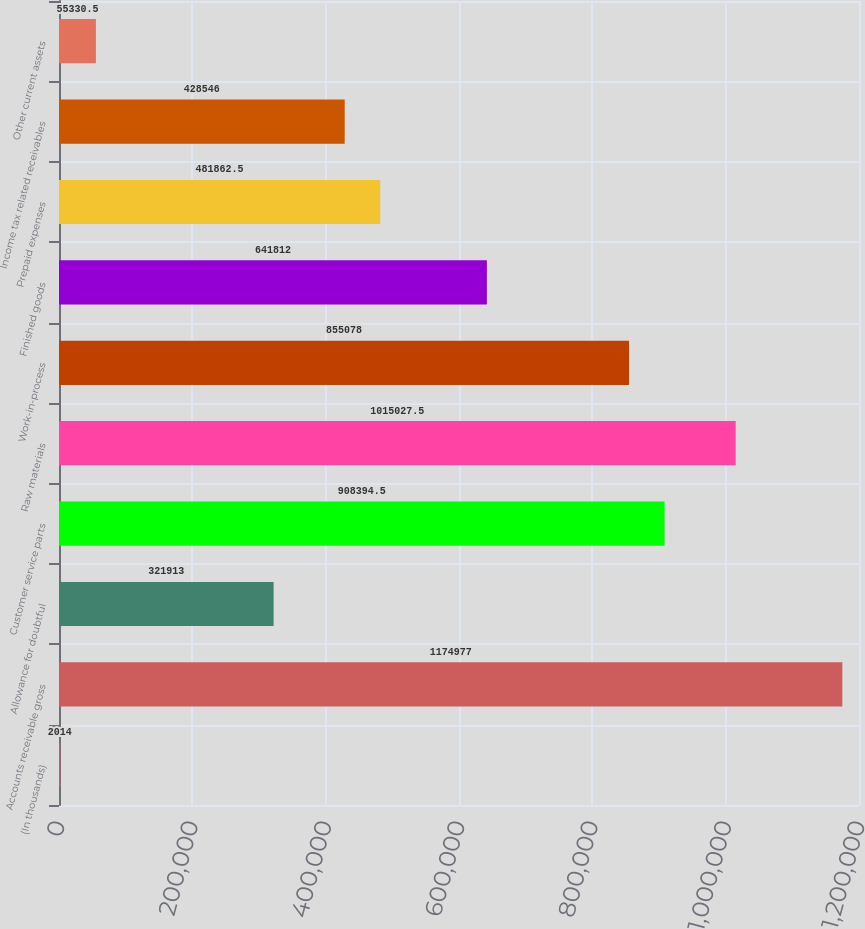Convert chart. <chart><loc_0><loc_0><loc_500><loc_500><bar_chart><fcel>(In thousands)<fcel>Accounts receivable gross<fcel>Allowance for doubtful<fcel>Customer service parts<fcel>Raw materials<fcel>Work-in-process<fcel>Finished goods<fcel>Prepaid expenses<fcel>Income tax related receivables<fcel>Other current assets<nl><fcel>2014<fcel>1.17498e+06<fcel>321913<fcel>908394<fcel>1.01503e+06<fcel>855078<fcel>641812<fcel>481862<fcel>428546<fcel>55330.5<nl></chart> 